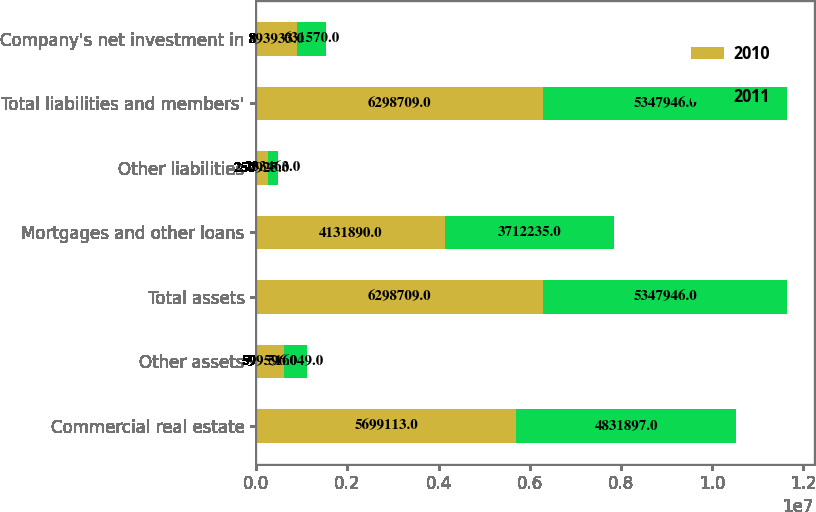Convert chart to OTSL. <chart><loc_0><loc_0><loc_500><loc_500><stacked_bar_chart><ecel><fcel>Commercial real estate<fcel>Other assets<fcel>Total assets<fcel>Mortgages and other loans<fcel>Other liabilities<fcel>Total liabilities and members'<fcel>Company's net investment in<nl><fcel>2010<fcel>5.69911e+06<fcel>599596<fcel>6.29871e+06<fcel>4.13189e+06<fcel>250925<fcel>6.29871e+06<fcel>893933<nl><fcel>2011<fcel>4.8319e+06<fcel>516049<fcel>5.34795e+06<fcel>3.71224e+06<fcel>233463<fcel>5.34795e+06<fcel>631570<nl></chart> 